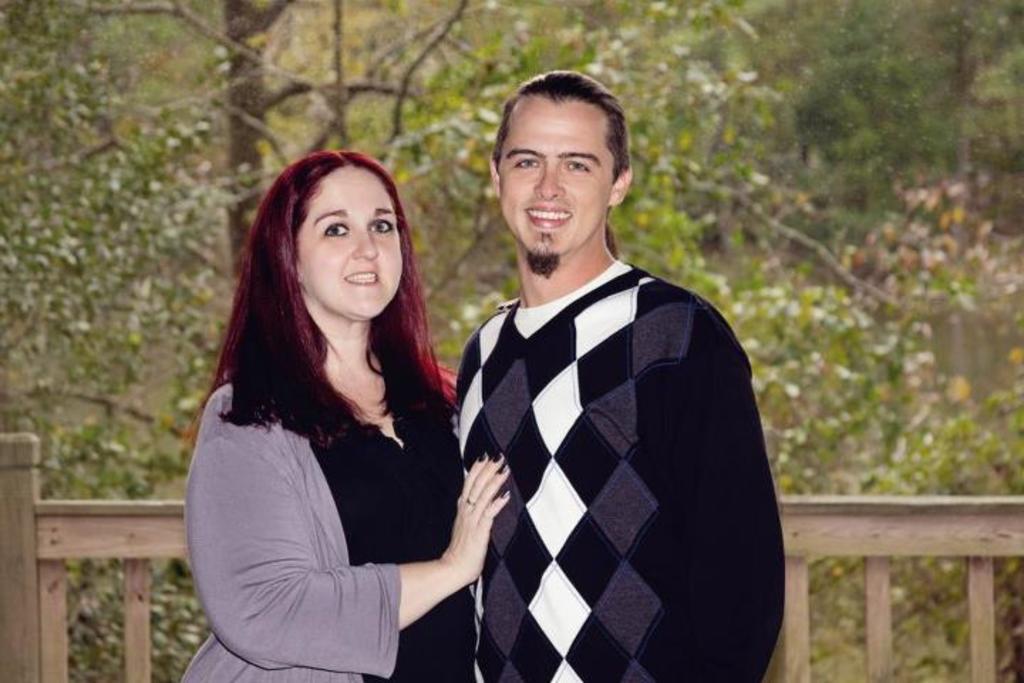How would you summarize this image in a sentence or two? In this picture we can see two people standing and smiling. We can see a wooden fence, plants and trees in the background. 